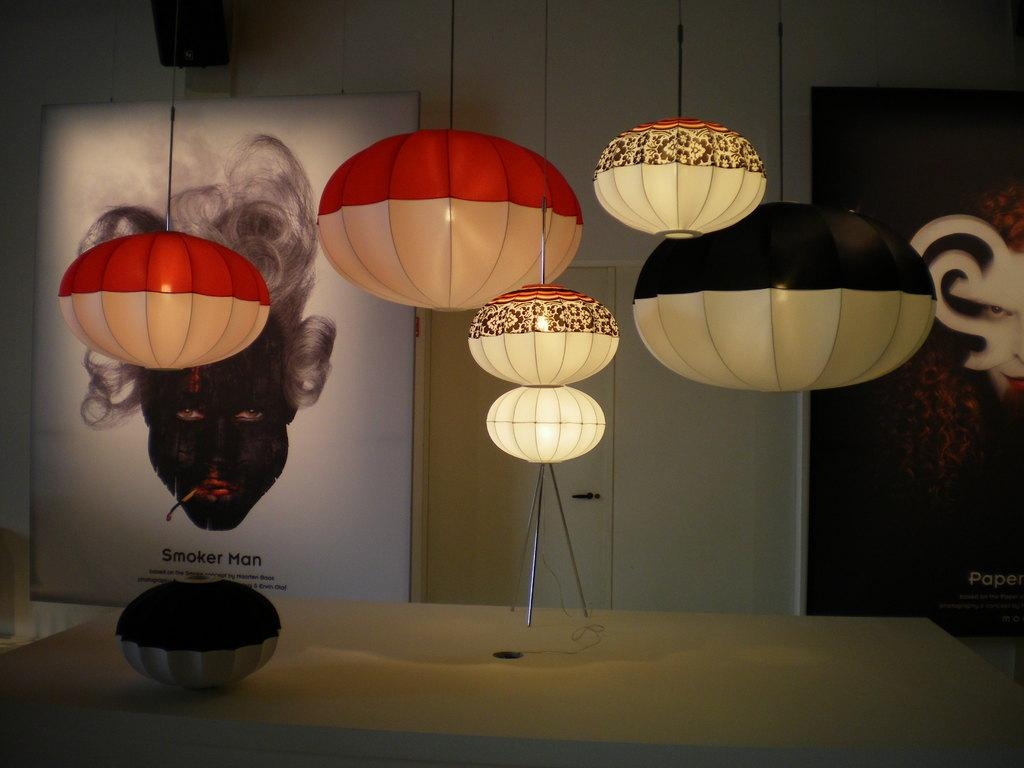What type of lamps are featured in the image? There are lamps in the shape of pumpkins in the image. How are the lamps positioned in the room? The lamps are hanged from the ceiling. What can be observed about the colors of the lamps? The lamps have different colors. What can be seen in the background of the image? There is a wall with paintings in the background of the image. Can you describe the ocean visible in the image? There is no ocean present in the image; it features pumpkin-shaped lamps hanging from the ceiling. What type of ray is depicted in one of the paintings on the wall? There is no ray depicted in any of the paintings on the wall in the image. 